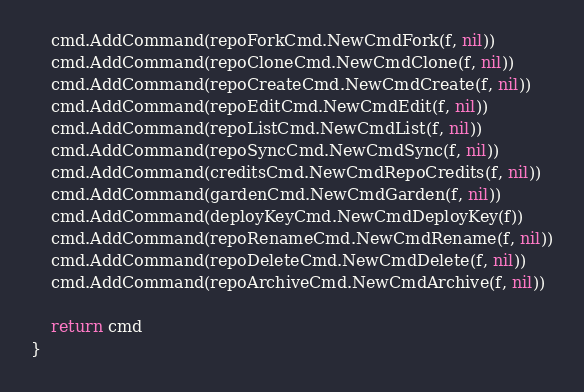<code> <loc_0><loc_0><loc_500><loc_500><_Go_>	cmd.AddCommand(repoForkCmd.NewCmdFork(f, nil))
	cmd.AddCommand(repoCloneCmd.NewCmdClone(f, nil))
	cmd.AddCommand(repoCreateCmd.NewCmdCreate(f, nil))
	cmd.AddCommand(repoEditCmd.NewCmdEdit(f, nil))
	cmd.AddCommand(repoListCmd.NewCmdList(f, nil))
	cmd.AddCommand(repoSyncCmd.NewCmdSync(f, nil))
	cmd.AddCommand(creditsCmd.NewCmdRepoCredits(f, nil))
	cmd.AddCommand(gardenCmd.NewCmdGarden(f, nil))
	cmd.AddCommand(deployKeyCmd.NewCmdDeployKey(f))
	cmd.AddCommand(repoRenameCmd.NewCmdRename(f, nil))
	cmd.AddCommand(repoDeleteCmd.NewCmdDelete(f, nil))
	cmd.AddCommand(repoArchiveCmd.NewCmdArchive(f, nil))

	return cmd
}
</code> 